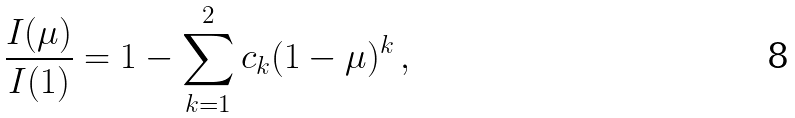<formula> <loc_0><loc_0><loc_500><loc_500>\frac { I ( \mu ) } { I ( 1 ) } = 1 - \sum _ { k = 1 } ^ { 2 } c _ { k } ( 1 - \mu ) ^ { k } \, ,</formula> 